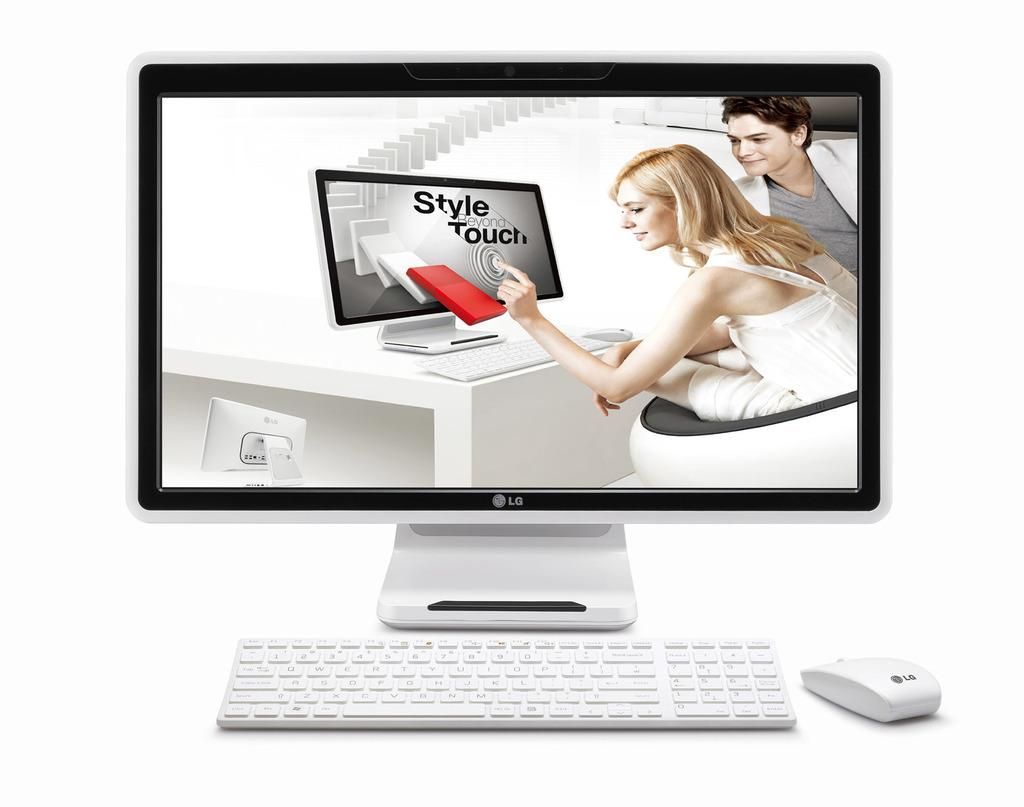What type of furniture is present in the image? There is a desktop in the image. What is displayed on the desktop? The desktop displays a picture. What is placed in front of the desktop for input? There is a keyboard in front of the desktop. What is placed in front of the desktop for navigation? There is a mouse in front of the desktop. What type of curtain is hanging on the wall behind the desktop? There is no curtain present in the image; the wall behind the desktop is visible. 